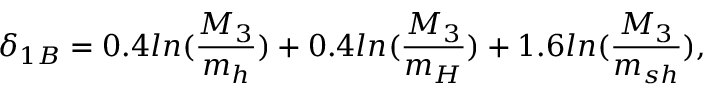Convert formula to latex. <formula><loc_0><loc_0><loc_500><loc_500>\delta _ { 1 B } = 0 . 4 \ln ( \frac { M _ { 3 } } { m _ { h } } ) + 0 . 4 \ln ( \frac { M _ { 3 } } { m _ { H } } ) + 1 . 6 \ln ( \frac { M _ { 3 } } { m _ { s h } } ) ,</formula> 